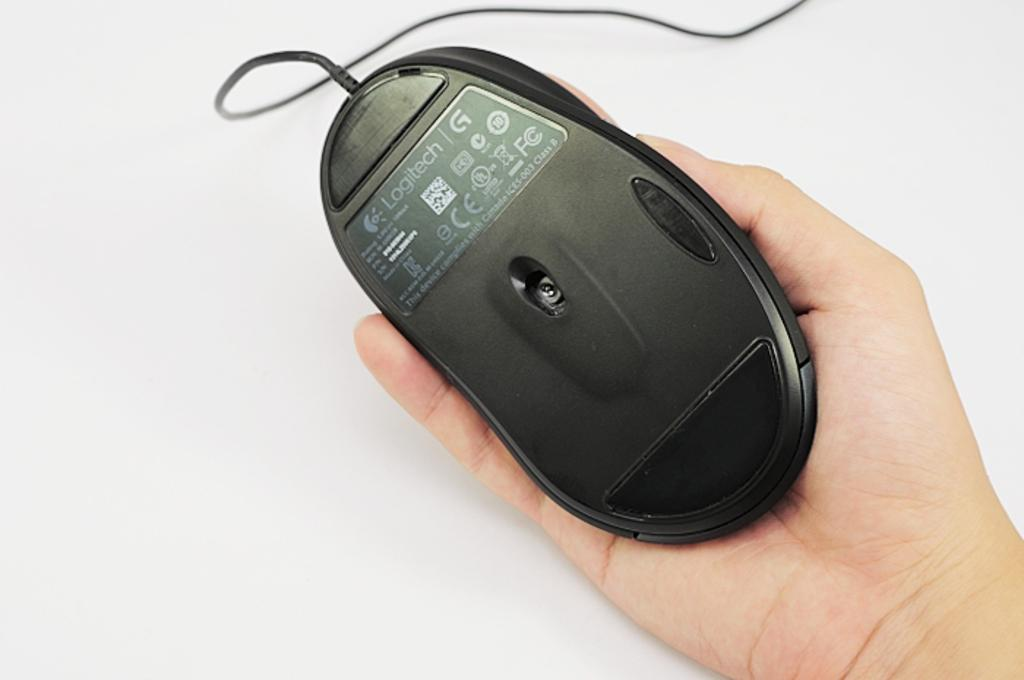What is the main subject of the image? There is a person in the image. What is the person holding in the image? The person is holding a mouse. Can you describe the color of the mouse? The mouse is black in color. What is the background of the image? There is a white background in the image. How many hands are visible in the image? There is no mention of hands in the image, as the person is holding a mouse. 